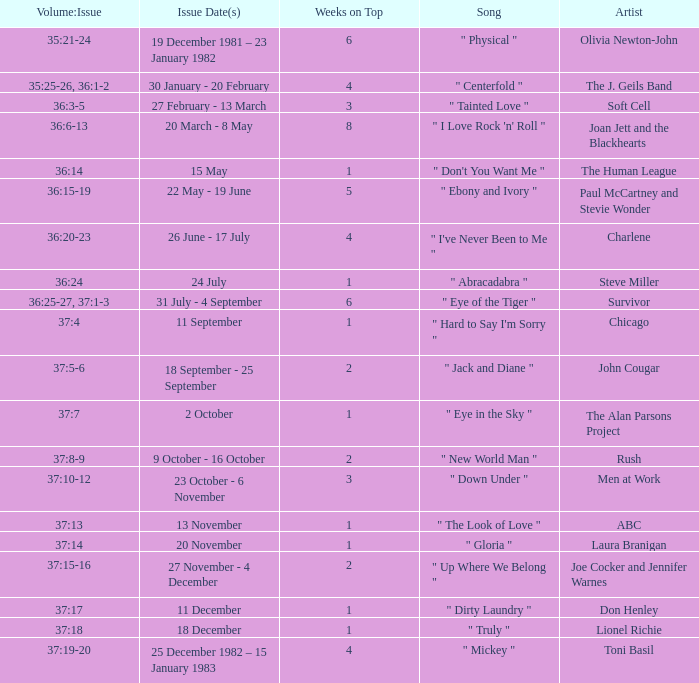Which Issue Date(s) has an Artist of men at work? 23 October - 6 November. 